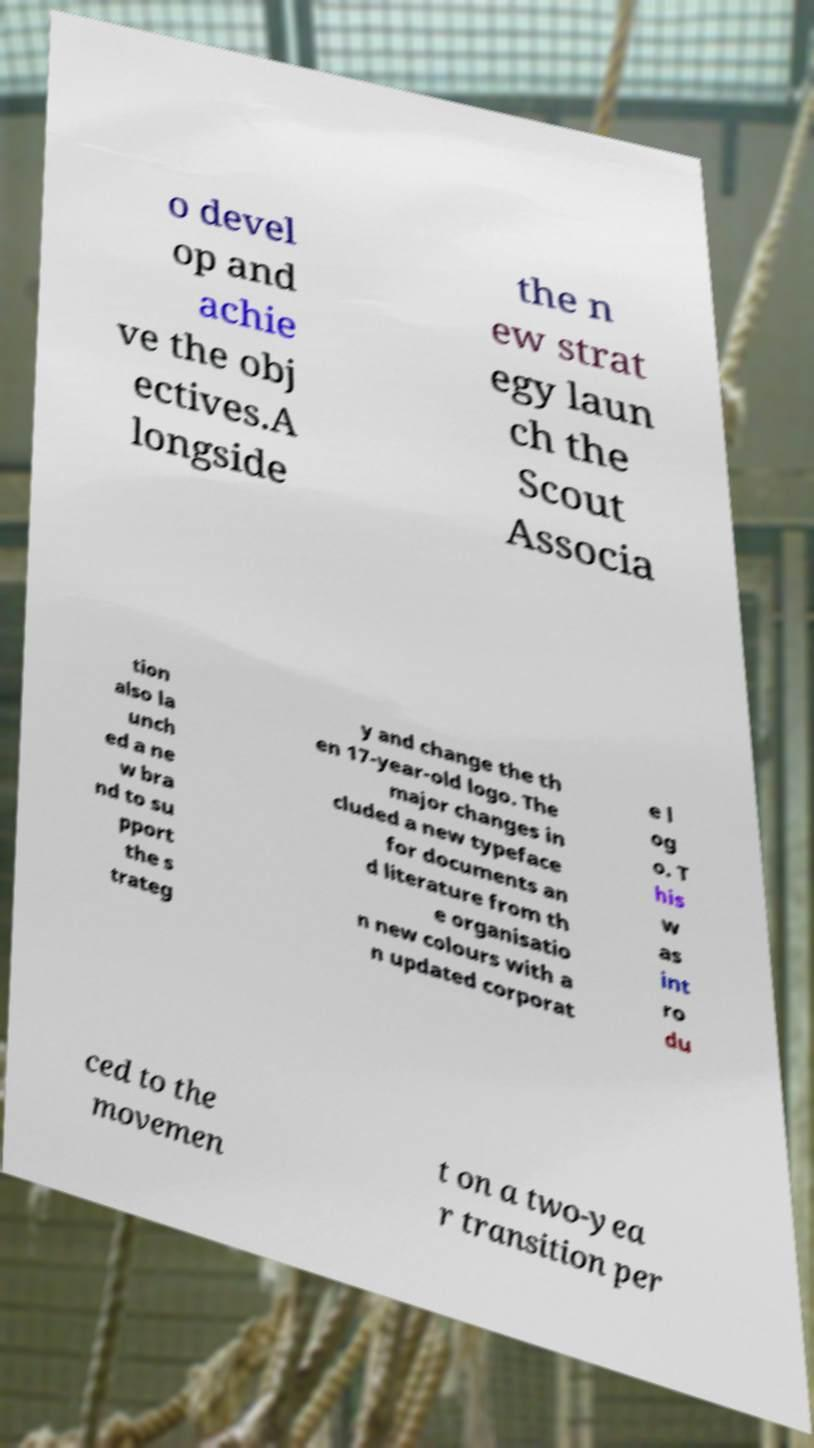For documentation purposes, I need the text within this image transcribed. Could you provide that? o devel op and achie ve the obj ectives.A longside the n ew strat egy laun ch the Scout Associa tion also la unch ed a ne w bra nd to su pport the s trateg y and change the th en 17-year-old logo. The major changes in cluded a new typeface for documents an d literature from th e organisatio n new colours with a n updated corporat e l og o. T his w as int ro du ced to the movemen t on a two-yea r transition per 